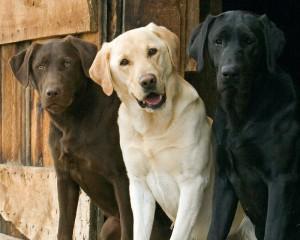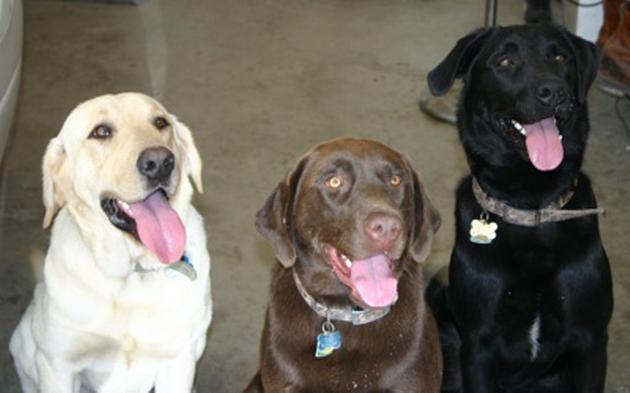The first image is the image on the left, the second image is the image on the right. Assess this claim about the two images: "There is a white (or lighter-colored) dog sitting in between two darker colored dogs in each image". Correct or not? Answer yes or no. No. The first image is the image on the left, the second image is the image on the right. For the images shown, is this caption "The right image has a black dog furthest to the left that is seated next to a white dog." true? Answer yes or no. No. 